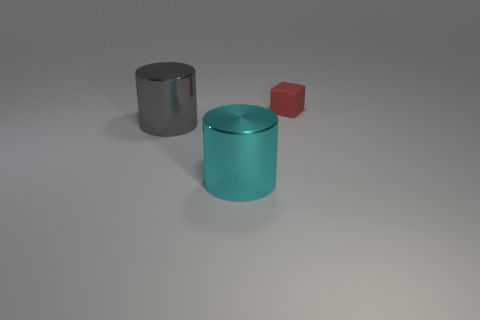How many rubber cubes are on the left side of the metal cylinder that is behind the large shiny object in front of the gray cylinder?
Ensure brevity in your answer.  0. There is a shiny cylinder that is the same size as the gray object; what color is it?
Your answer should be very brief. Cyan. There is a metal object that is to the right of the thing that is to the left of the cyan metallic thing; what size is it?
Give a very brief answer. Large. How many other things are there of the same size as the matte object?
Ensure brevity in your answer.  0. How many small matte blocks are there?
Offer a very short reply. 1. Is the size of the red matte cube the same as the cyan thing?
Give a very brief answer. No. How many other objects are there of the same shape as the gray thing?
Provide a short and direct response. 1. There is a cylinder behind the cylinder that is in front of the gray object; what is its material?
Your answer should be very brief. Metal. Are there any cylinders on the left side of the cyan metallic cylinder?
Give a very brief answer. Yes. There is a red thing; does it have the same size as the metallic cylinder left of the cyan object?
Provide a short and direct response. No. 